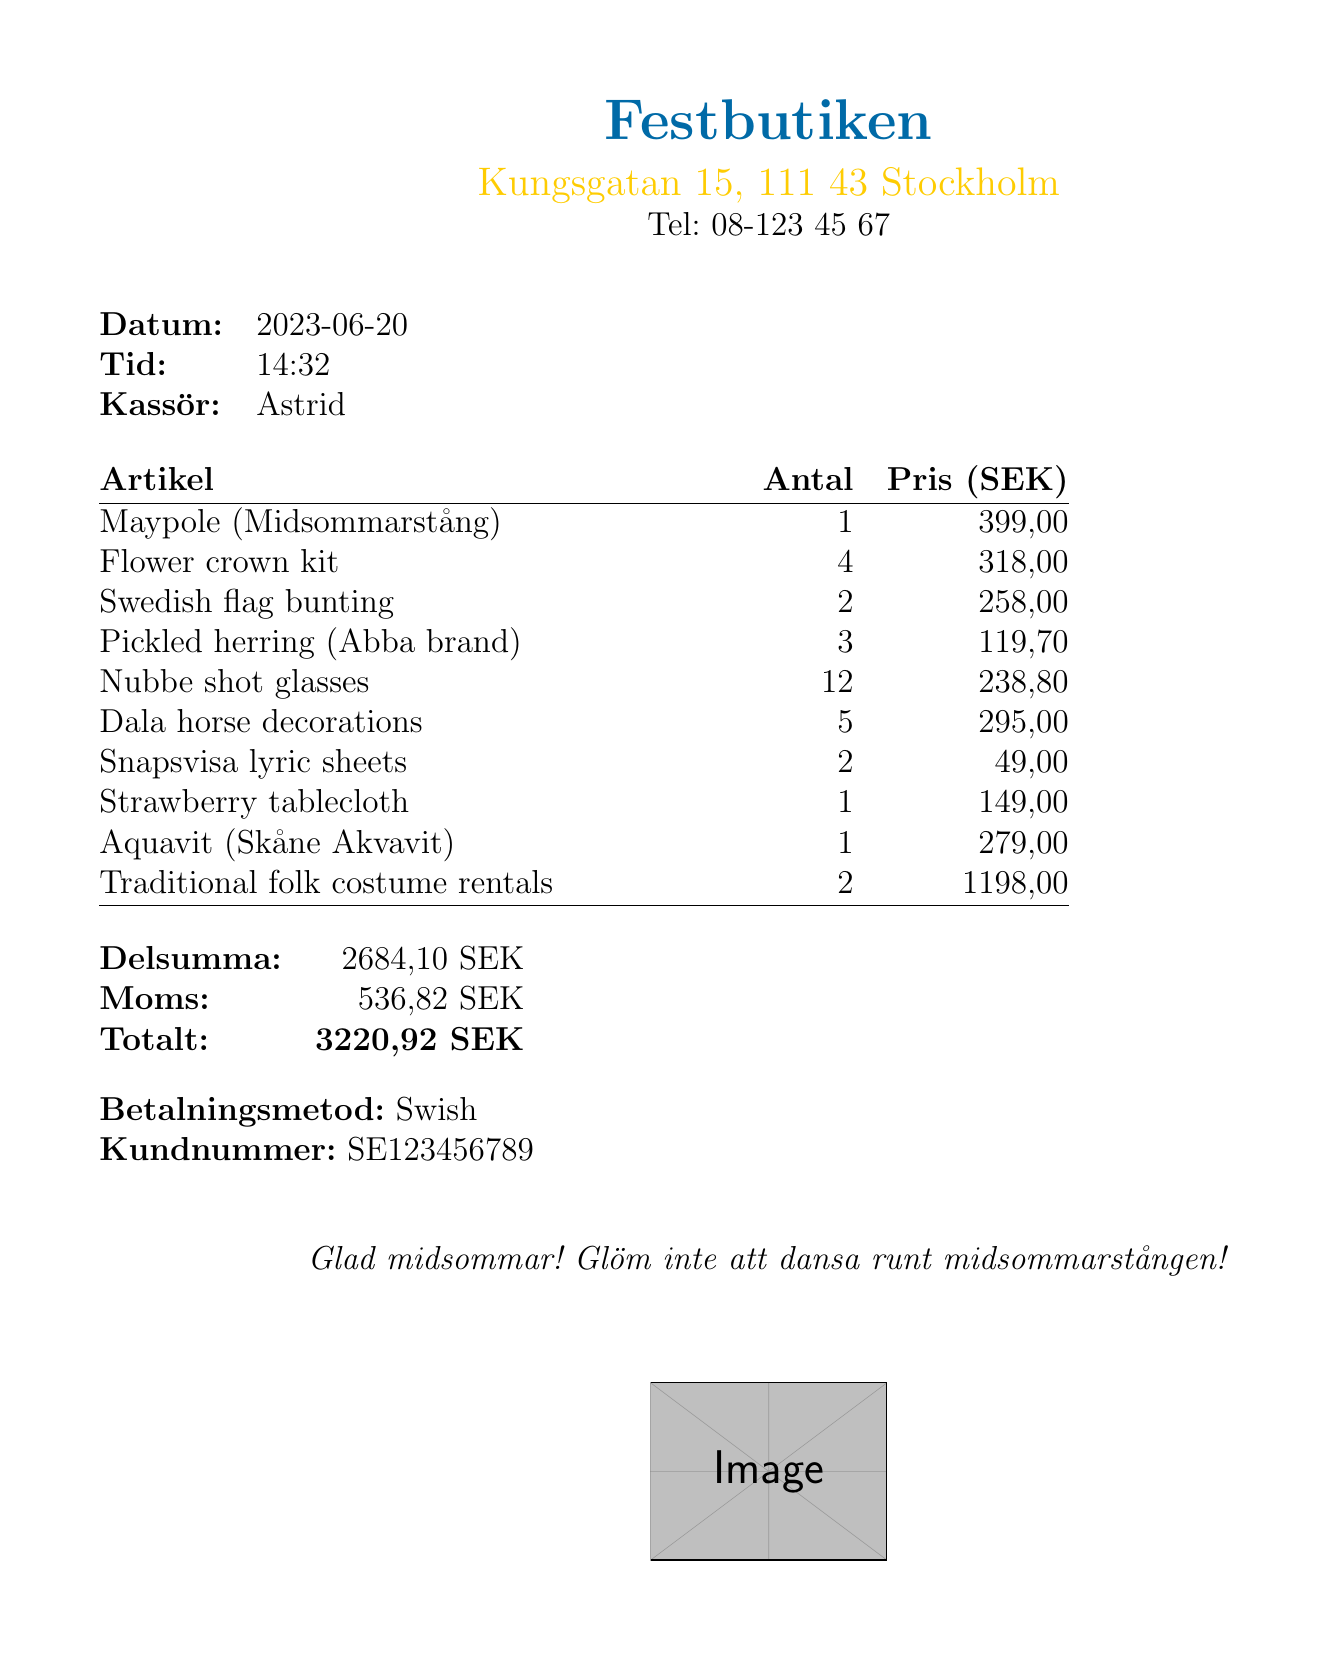What is the name of the store? The store name is prominently displayed at the top of the receipt.
Answer: Festbutiken What is the date of the purchase? The date of the purchase is listed in the header section of the receipt.
Answer: 2023-06-20 How many flower crown kits were purchased? The quantity of flower crown kits is indicated alongside the item description on the receipt.
Answer: 4 What is the total amount charged? The total amount charged is clearly mentioned at the bottom of the receipt.
Answer: 3220,92 SEK Who was the cashier? The cashier's name is provided in the receipt details section.
Answer: Astrid What is the payment method used? The payment method is stated in the lower section of the receipt.
Answer: Swish How many Dala horse decorations were bought? The number of Dala horse decorations is specified next to the item in the item list.
Answer: 5 What is the price of the Maypole? The price of the Maypole can be found next to its name in the itemized list.
Answer: 399,00 Is there a special note on the receipt? The special note is written in italics at the bottom of the receipt.
Answer: Glad midsommar! Don't forget to dance around the maypole! 